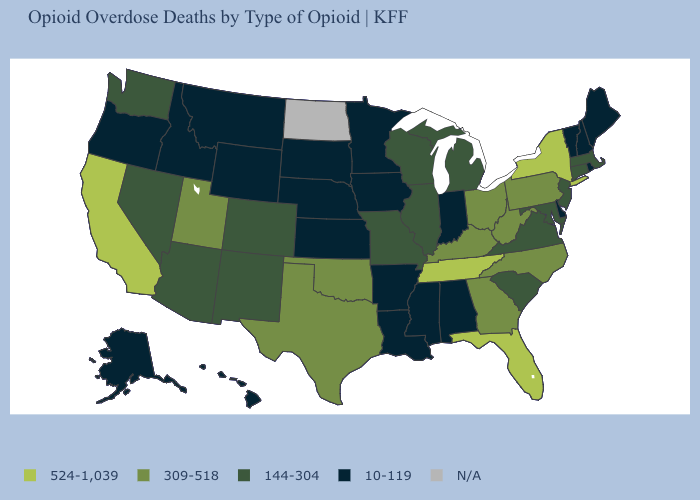What is the value of Kansas?
Answer briefly. 10-119. What is the highest value in the MidWest ?
Answer briefly. 309-518. What is the value of New Jersey?
Write a very short answer. 144-304. What is the value of Illinois?
Quick response, please. 144-304. What is the value of Delaware?
Be succinct. 10-119. Which states have the lowest value in the USA?
Write a very short answer. Alabama, Alaska, Arkansas, Delaware, Hawaii, Idaho, Indiana, Iowa, Kansas, Louisiana, Maine, Minnesota, Mississippi, Montana, Nebraska, New Hampshire, Oregon, Rhode Island, South Dakota, Vermont, Wyoming. Does Connecticut have the lowest value in the Northeast?
Give a very brief answer. No. Does Maryland have the lowest value in the South?
Quick response, please. No. Name the states that have a value in the range 309-518?
Write a very short answer. Georgia, Kentucky, North Carolina, Ohio, Oklahoma, Pennsylvania, Texas, Utah, West Virginia. Name the states that have a value in the range N/A?
Give a very brief answer. North Dakota. Among the states that border Michigan , does Ohio have the lowest value?
Answer briefly. No. What is the value of Illinois?
Write a very short answer. 144-304. Name the states that have a value in the range N/A?
Quick response, please. North Dakota. What is the lowest value in the USA?
Answer briefly. 10-119. 